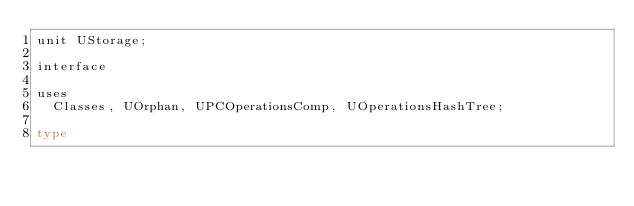Convert code to text. <code><loc_0><loc_0><loc_500><loc_500><_Pascal_>unit UStorage;

interface

uses
  Classes, UOrphan, UPCOperationsComp, UOperationsHashTree;

type</code> 